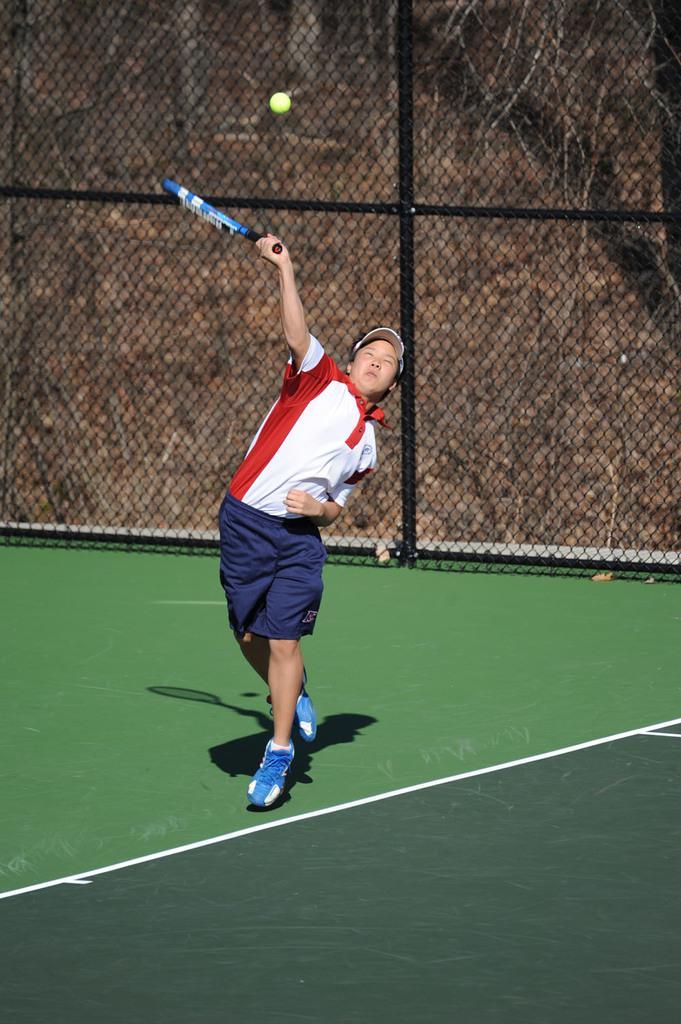Please provide a concise description of this image. In this image I can see a person wearing white, red and blue colored dress is holding a bat in his hand and I can see a ball over here. In the background I can see the black colored railing, the tennis court, the ground and few trees. 